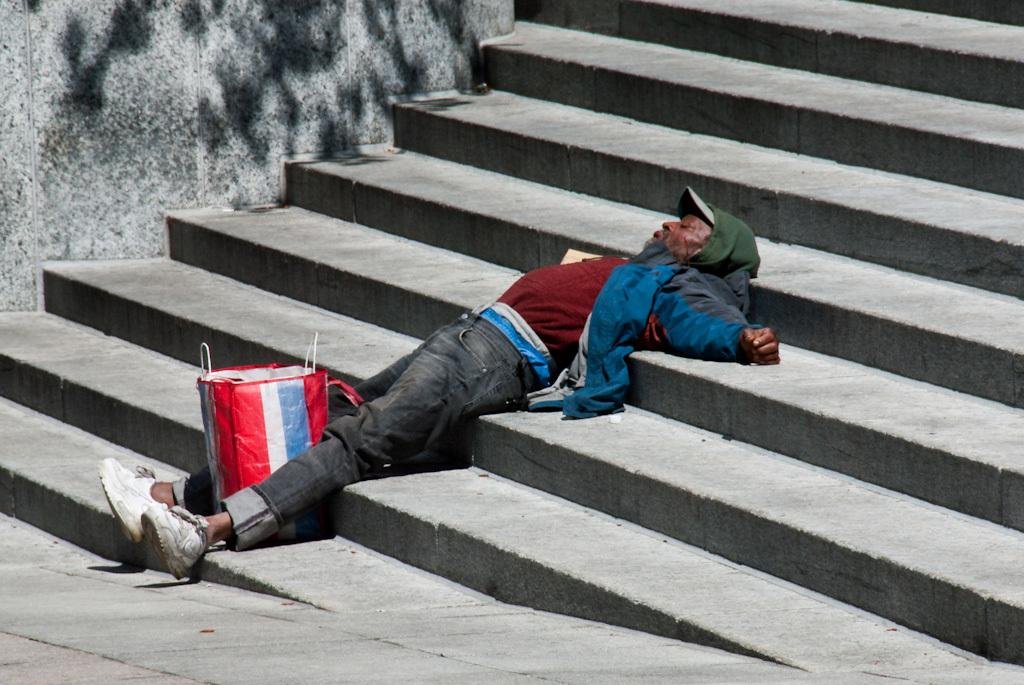Who is present in the image? There is a man in the image. What is the man doing in the image? The man is lying on steps. What object is located between the man's legs? There is a bag between the man's legs. What can be seen in the background of the image? There is a wall in the background of the image. What type of development is taking place on the plate in the image? There is no plate present in the image, and therefore no development can be observed. 